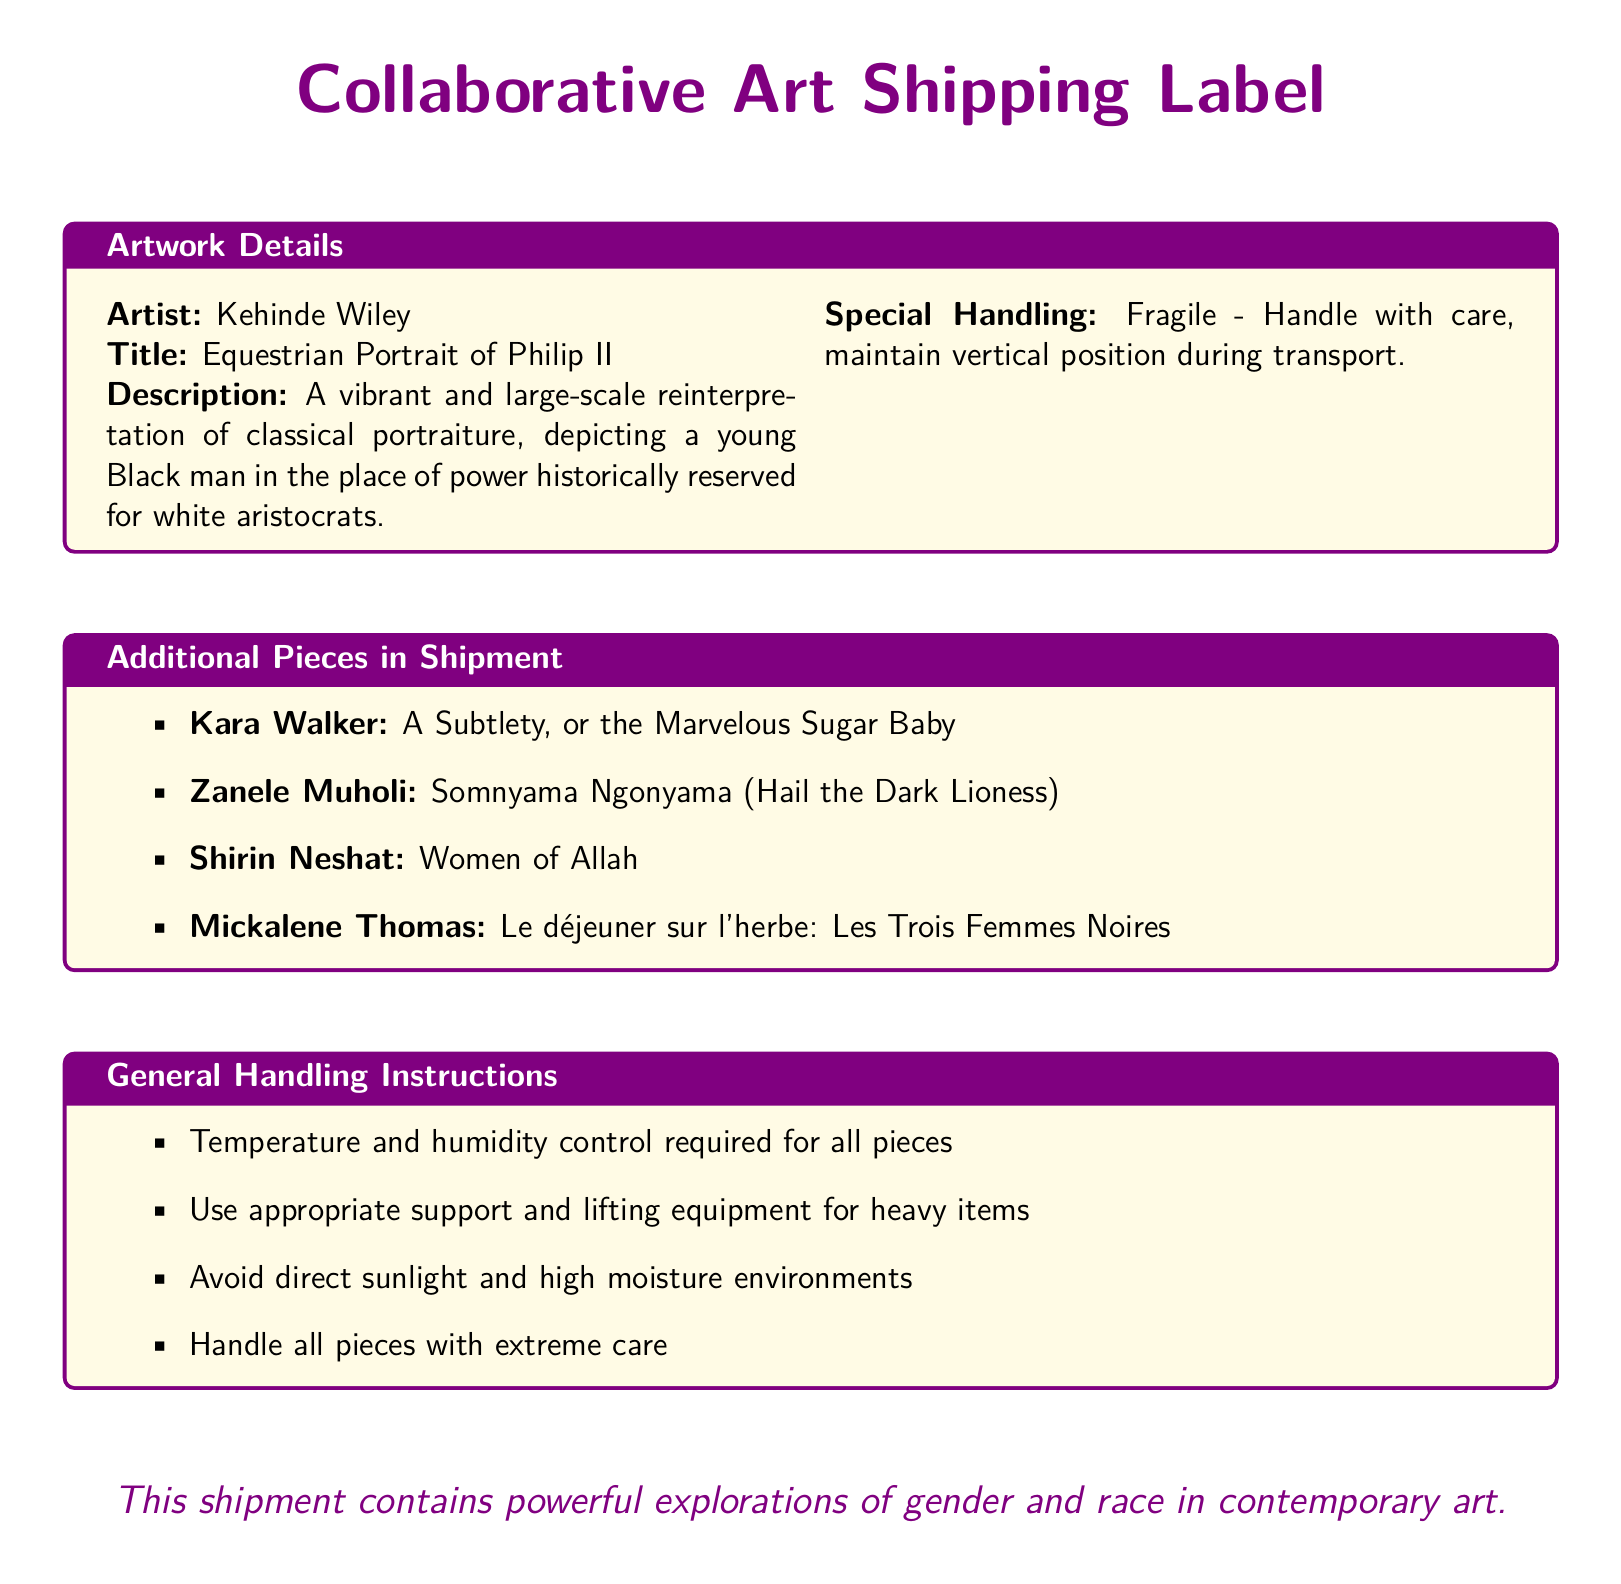what is the title of Kehinde Wiley's artwork? The title of Kehinde Wiley's artwork is mentioned in the document as "Equestrian Portrait of Philip II."
Answer: Equestrian Portrait of Philip II what is the primary color mentioned for the fragile item? The document specifies that the fragile item needs to be handled with care and implies a focus on case colors such as purple and gold. The color purple is emphasized as part of the title.
Answer: Purple how many additional pieces are listed in the shipment? The shipment includes a list of additional pieces that is contained in a tcolorbox, which enumerates four artworks.
Answer: 4 who created "Somnyama Ngonyama"? The document lists Zanele Muholi as the artist for the artwork "Somnyama Ngonyama."
Answer: Zanele Muholi what special handling instruction is given for all pieces? General handling instructions state that temperature and humidity control is required for all pieces.
Answer: Temperature and humidity control which artist's work depicts a young Black man in a position of power? The artwork description highlights Kehinde Wiley's depiction of a young Black man in a place of power, historically reserved for white aristocrats.
Answer: Kehinde Wiley what should be avoided during the handling of the artworks? The general handling instructions caution to avoid direct sunlight and high moisture environments during the handling of the artworks.
Answer: Direct sunlight what is the overall theme indicated in the document? The document expresses that the shipment contains powerful explorations of gender and race in contemporary art, highlighting its thematic significance.
Answer: Gender and race in contemporary art 